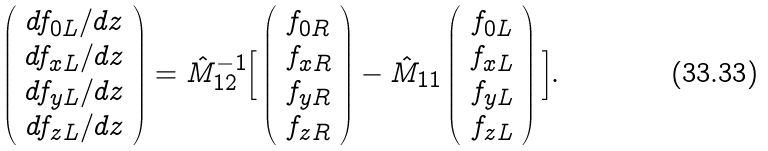<formula> <loc_0><loc_0><loc_500><loc_500>\left ( \begin{array} { c } d f _ { 0 L } / d z \\ d f _ { x L } / d z \\ d f _ { y L } / d z \\ d f _ { z L } / d z \end{array} \right ) = \hat { M } _ { 1 2 } ^ { - 1 } \Big { [ } \left ( \begin{array} { c } f _ { 0 R } \\ f _ { x R } \\ f _ { y R } \\ f _ { z R } \end{array} \right ) - \hat { M } _ { 1 1 } \left ( \begin{array} { c } f _ { 0 L } \\ f _ { x L } \\ f _ { y L } \\ f _ { z L } \end{array} \right ) \Big { ] } .</formula> 